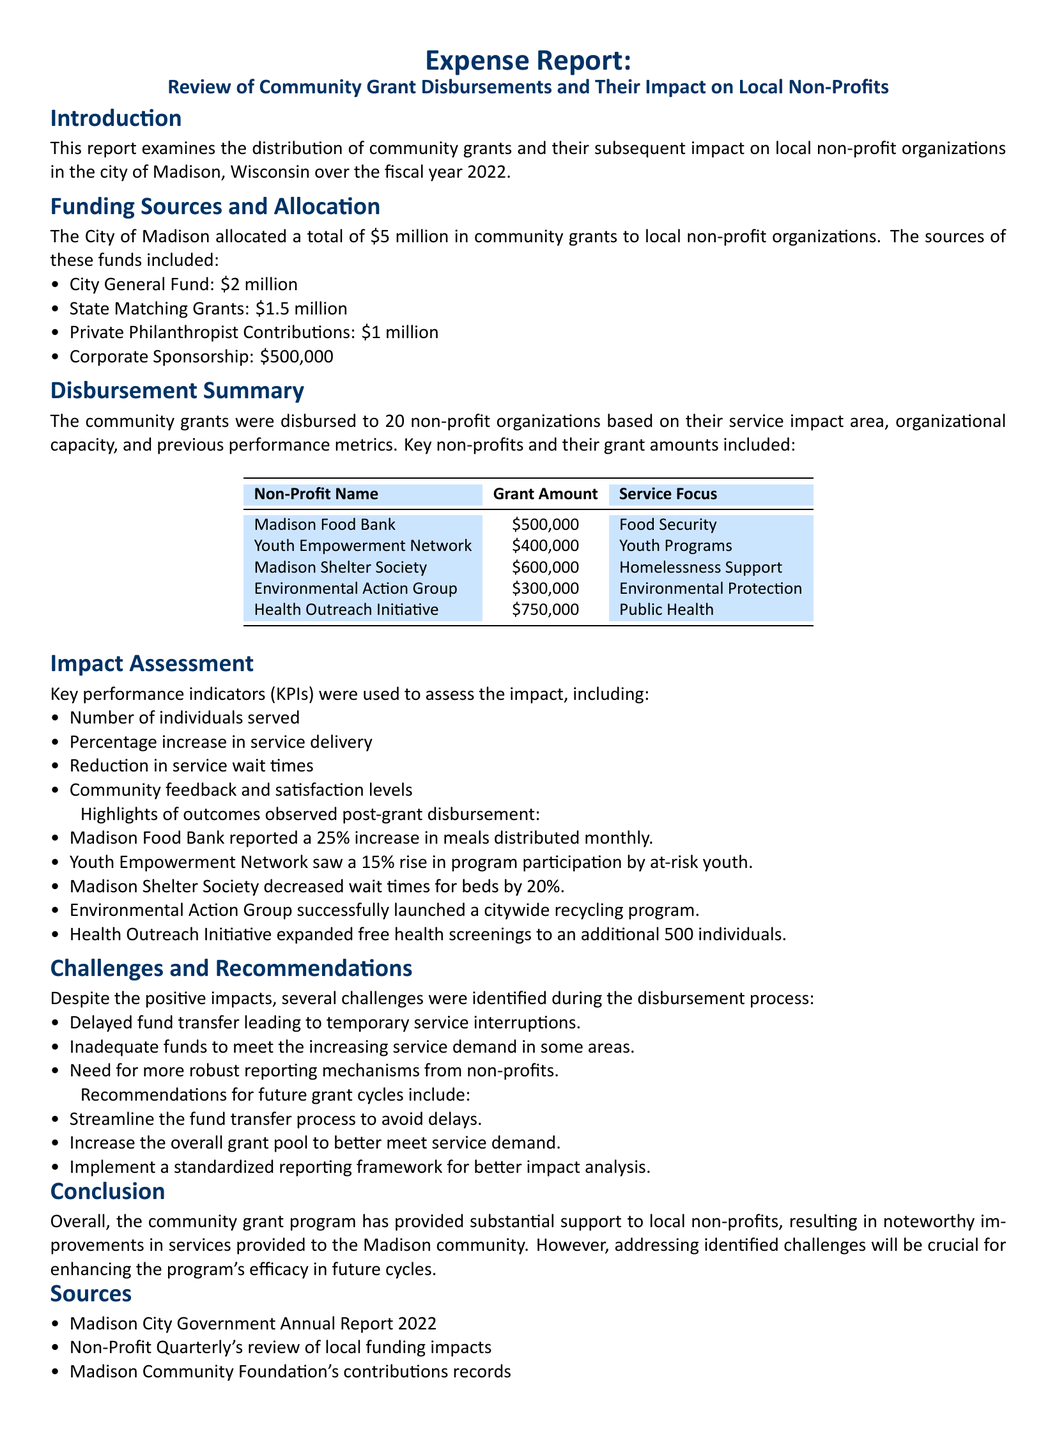What was the total amount allocated for community grants? The total amount allocated is stated as $5 million in the document.
Answer: $5 million Which organization received the highest grant amount? The document lists the grant amounts for each non-profit, identifying Madison Shelter Society as the highest at $600,000.
Answer: Madison Shelter Society What percentage increase in meals distributed did the Madison Food Bank report? The document mentions the Madison Food Bank reported a 25% increase in meals distributed monthly.
Answer: 25% What is one challenge identified in the report? The report highlights several challenges, one of which is delayed fund transfer leading to temporary service interruptions.
Answer: Delayed fund transfer What is the service focus of the Health Outreach Initiative? The service focus of the Health Outreach Initiative is specified as Public Health in the table within the document.
Answer: Public Health How much funding did the Environmental Action Group receive? The document specifies that the Environmental Action Group was granted $300,000.
Answer: $300,000 What documentation is suggested for better impact analysis? The recommendations section advises implementing a standardized reporting framework for better impact analysis.
Answer: Standardized reporting framework Which funding source contributed the least to the total amount? The document indicates that Corporate Sponsorship contributed $500,000, which is the least among the sources listed.
Answer: Corporate Sponsorship 